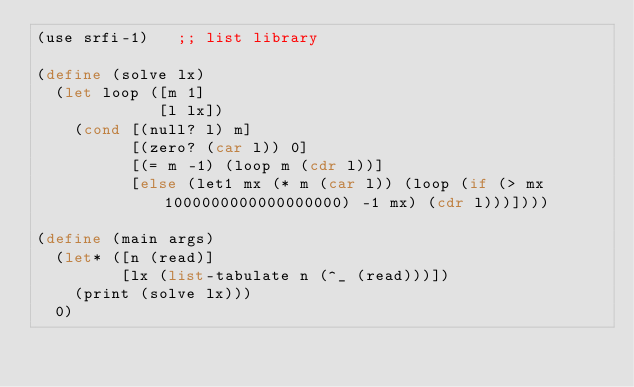Convert code to text. <code><loc_0><loc_0><loc_500><loc_500><_Scheme_>(use srfi-1)   ;; list library

(define (solve lx)
  (let loop ([m 1]
             [l lx])
    (cond [(null? l) m]
          [(zero? (car l)) 0]
          [(= m -1) (loop m (cdr l))]
          [else (let1 mx (* m (car l)) (loop (if (> mx 1000000000000000000) -1 mx) (cdr l)))])))

(define (main args)
  (let* ([n (read)]
         [lx (list-tabulate n (^_ (read)))])
    (print (solve lx)))
  0)
</code> 